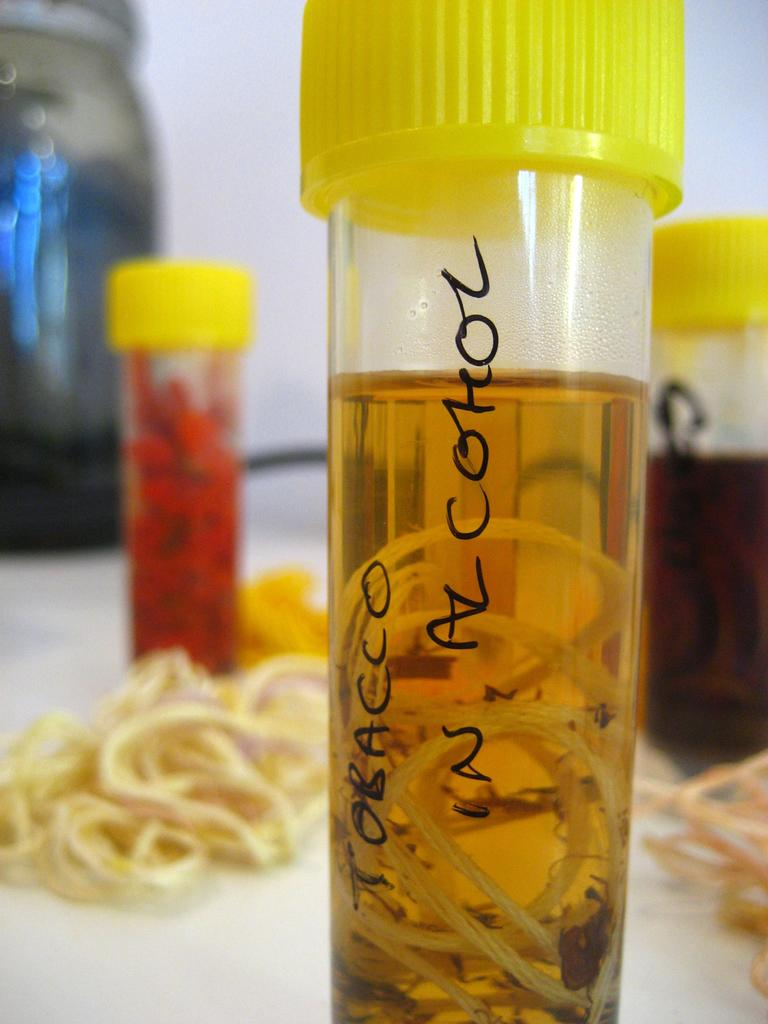What objects are on the table in the image? There are small sample bottles on the table in the image. What substance can be seen in the image? Tobacco is visible in the image. What sound can be heard coming from the town in the image? There is no town present in the image, so it is not possible to determine what sound might be heard. 